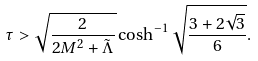Convert formula to latex. <formula><loc_0><loc_0><loc_500><loc_500>\tau > \sqrt { \frac { 2 } { 2 M ^ { 2 } + \tilde { \Lambda } } } \cosh ^ { - 1 } \sqrt { \frac { 3 + 2 \sqrt { 3 } } { 6 } } .</formula> 